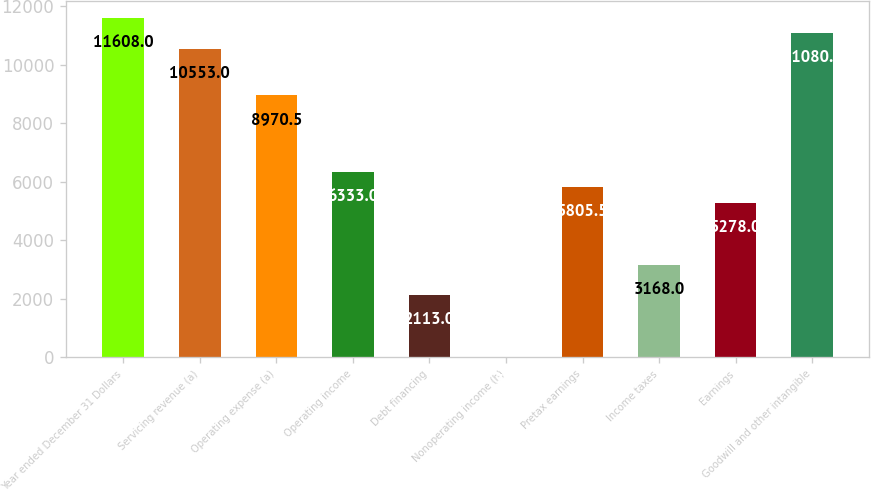Convert chart to OTSL. <chart><loc_0><loc_0><loc_500><loc_500><bar_chart><fcel>Year ended December 31 Dollars<fcel>Servicing revenue (a)<fcel>Operating expense (a)<fcel>Operating income<fcel>Debt financing<fcel>Nonoperating income (b)<fcel>Pretax earnings<fcel>Income taxes<fcel>Earnings<fcel>Goodwill and other intangible<nl><fcel>11608<fcel>10553<fcel>8970.5<fcel>6333<fcel>2113<fcel>3<fcel>5805.5<fcel>3168<fcel>5278<fcel>11080.5<nl></chart> 